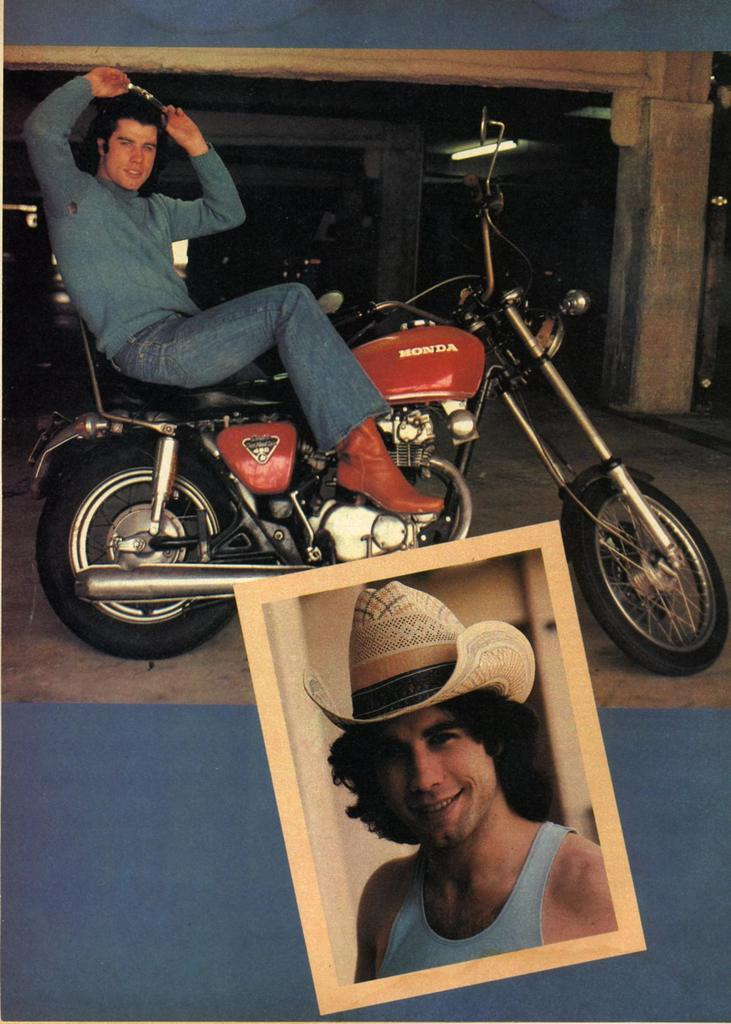What can be seen in the image that a person might use for transportation? There is a bike in the image that a person might use for transportation. Who is sitting on the bike in the image? A man is sitting on the bike in the image. What object in the image contains a photo? There is a photo frame in the image that contains a photo. What can be seen in the photo inside the frame? The photo inside the frame shows a man wearing a cap. What type of pest can be seen crawling on the bike in the image? There are no pests visible in the image; it only shows a bike, a man sitting on it, and a photo frame with a photo. 